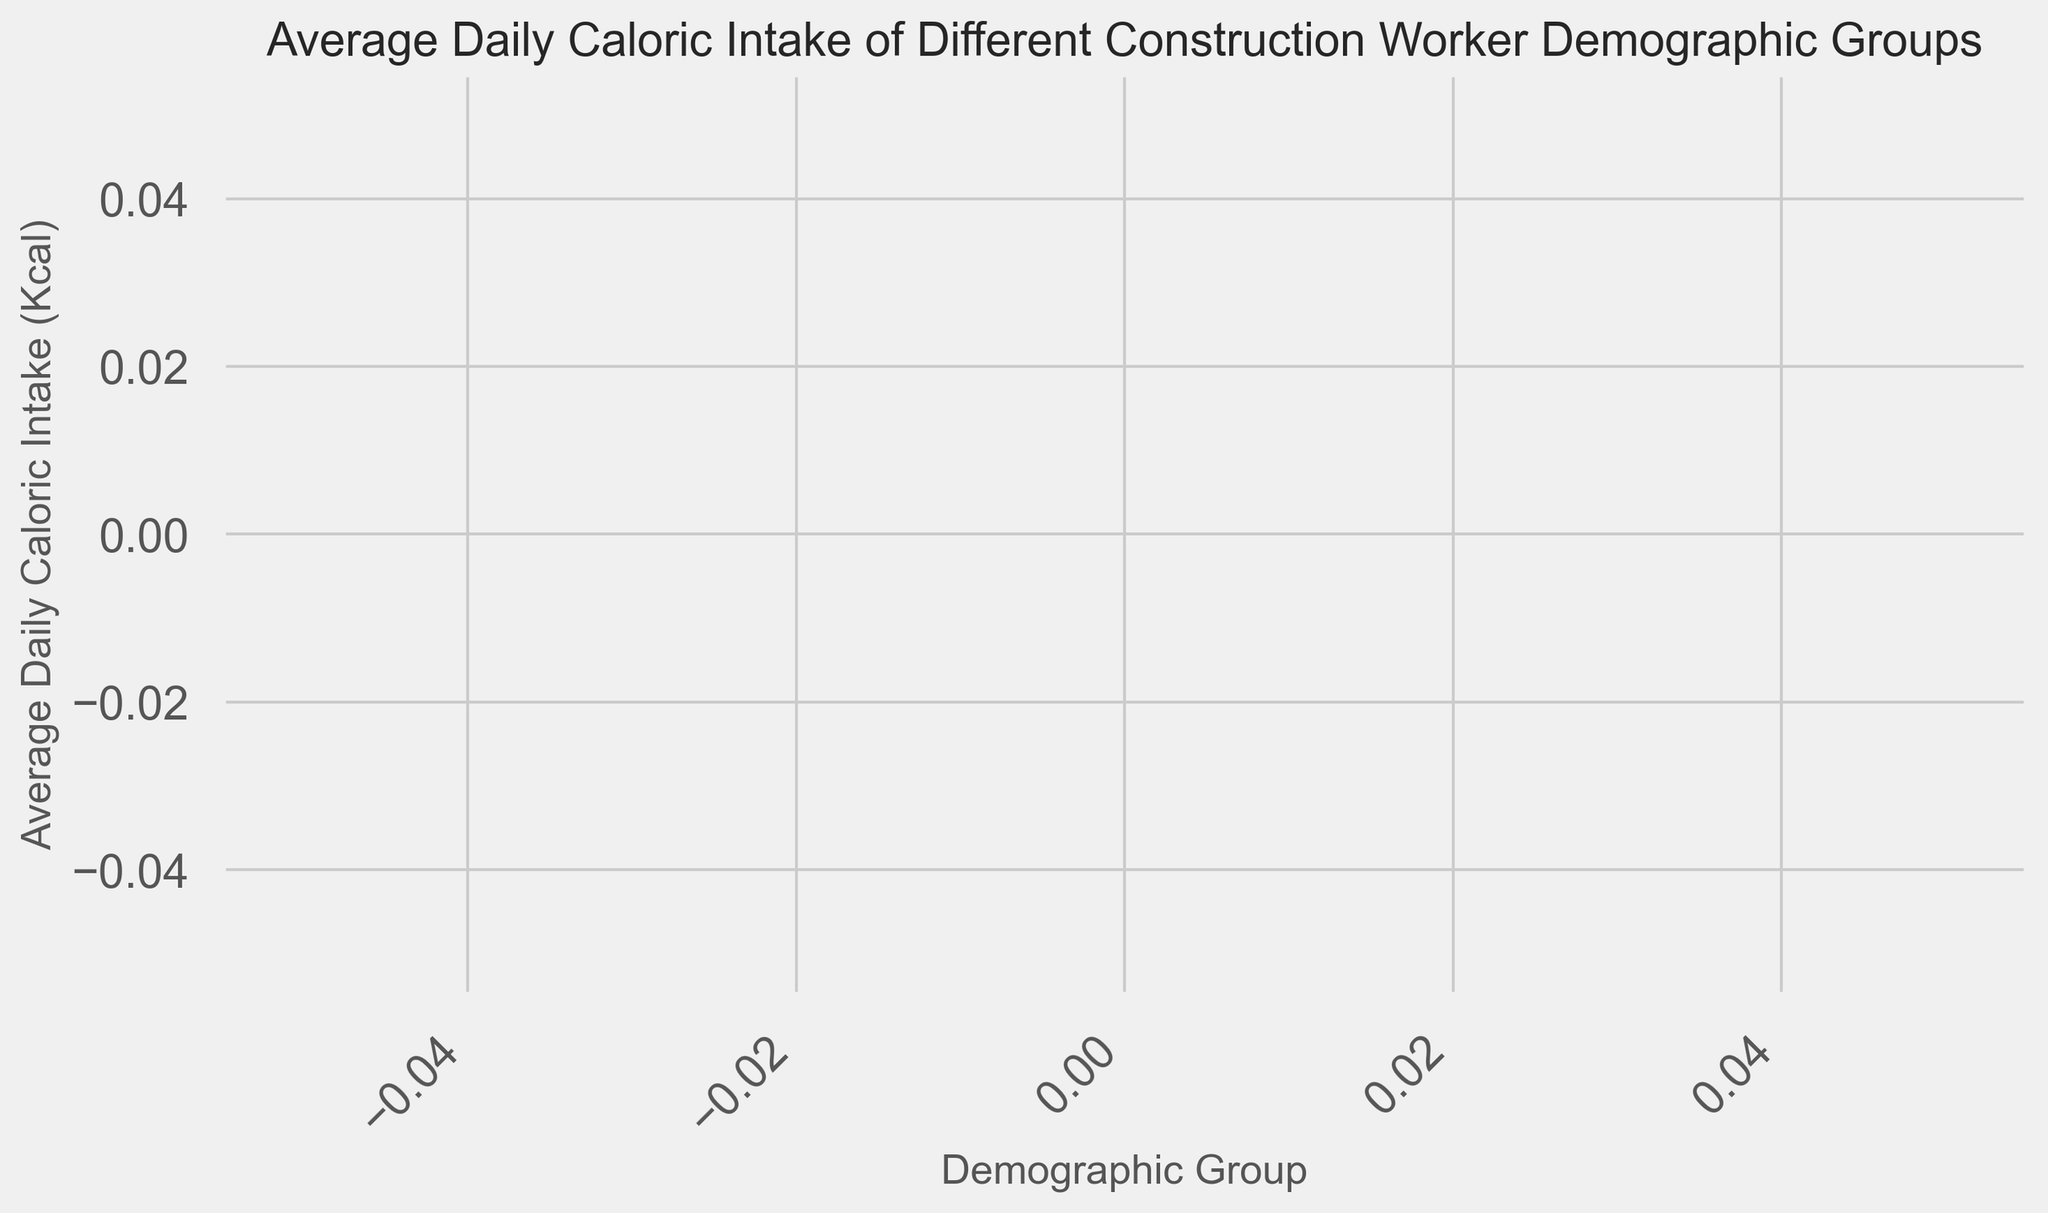Which demographic group has the highest average daily caloric intake? Inspect the bar chart and identify the tallest bar, which represents the demographic group with the highest average daily caloric intake. Compare all bars visually.
Answer: [Insert Group with the highest intake] Which demographic group has the lowest average daily caloric intake? Look at the bar chart and find the shortest bar, which shows the demographic group with the lowest average daily caloric intake. Compare the height of all bars.
Answer: [Insert Group with the lowest intake] What is the difference in average daily caloric intake between the group with the highest and the group with the lowest intake? First identify the groups with the highest and lowest average daily caloric intakes. Then, subtract the intake of the lowest group from the intake of the highest group to find the difference.
Answer: [Insert Difference] How does the average daily caloric intake of Group A compare to Group B? Compare the heights of the bars representing Group A and Group B. Identify whether the bar for Group A is taller, shorter, or equal in height to the one for Group B.
Answer: [Insert Comparison] What's the average of the average daily caloric intakes for all demographic groups? Sum the average daily caloric intakes for all demographic groups and then divide by the number of groups to find the average value.
Answer: [Insert Average] Which demographic group is closest to the overall average daily caloric intake? Calculate the overall average caloric intake. Compare the average intake of each group to see which one is closest to this overall average. This involves finding the absolute difference between each group’s intake and the overall average.
Answer: [Insert Closest Group] How many groups have a caloric intake above 3000 Kcal? Count the number of bars that are taller than the level corresponding to 3000 Kcal on the y-axis.
Answer: [Insert Number of Groups] What's the range of average daily caloric intake among the demographic groups? Identify the highest and lowest average daily caloric intakes. Subtract the lowest value from the highest to find the range.
Answer: [Insert Range] Is the bar for any demographic group exactly equal to the average caloric intake? Calculate the average caloric intake. Inspect the bars to see if any bar exactly matches this average value.
Answer: [Yes/No] What is the total sum of the average daily caloric intakes for all groups combined? Sum the average daily caloric intakes for all demographic groups shown in the bar chart.
Answer: [Insert Total Sum] 